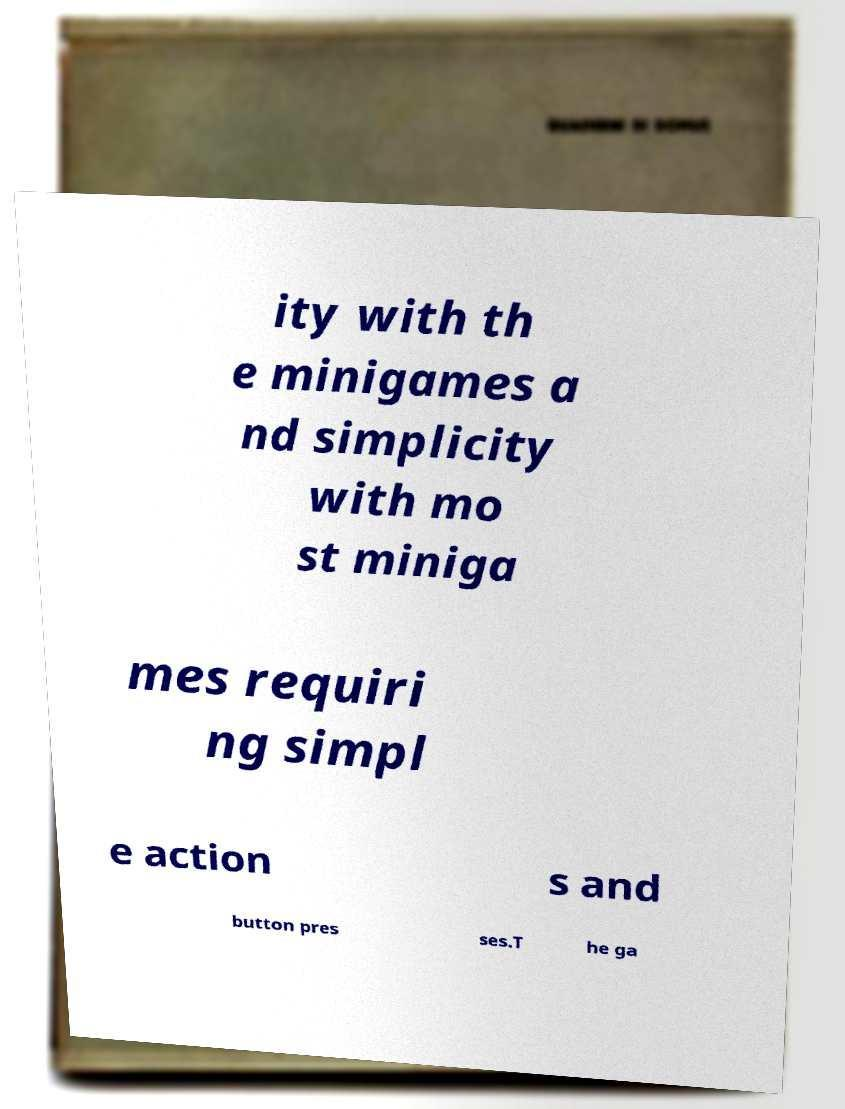What messages or text are displayed in this image? I need them in a readable, typed format. ity with th e minigames a nd simplicity with mo st miniga mes requiri ng simpl e action s and button pres ses.T he ga 